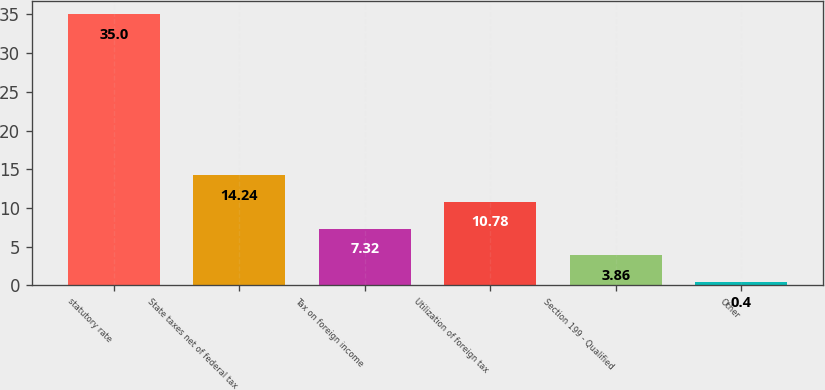Convert chart to OTSL. <chart><loc_0><loc_0><loc_500><loc_500><bar_chart><fcel>statutory rate<fcel>State taxes net of federal tax<fcel>Tax on foreign income<fcel>Utilization of foreign tax<fcel>Section 199 - Qualified<fcel>Other<nl><fcel>35<fcel>14.24<fcel>7.32<fcel>10.78<fcel>3.86<fcel>0.4<nl></chart> 